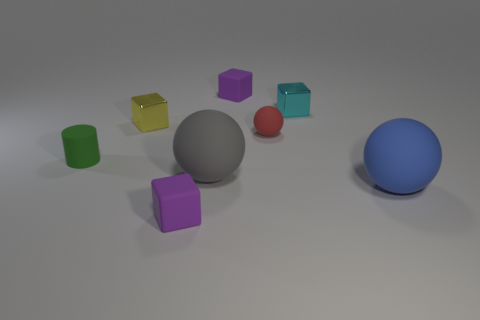Are there any other things that have the same material as the gray thing?
Your answer should be compact. Yes. How many small purple matte objects are to the right of the ball on the left side of the tiny purple cube behind the small rubber sphere?
Give a very brief answer. 1. What shape is the cyan thing that is the same material as the yellow thing?
Your response must be concise. Cube. The cyan cube that is in front of the purple matte object right of the small purple rubber thing that is in front of the small green matte object is made of what material?
Provide a succinct answer. Metal. How many things are purple objects in front of the blue ball or cyan things?
Provide a short and direct response. 2. What number of other objects are there of the same shape as the large blue matte object?
Give a very brief answer. 2. Are there more tiny cyan metallic objects that are to the right of the yellow shiny cube than small purple rubber cylinders?
Provide a short and direct response. Yes. There is a gray rubber object that is the same shape as the tiny red rubber thing; what size is it?
Your answer should be very brief. Large. The big blue thing has what shape?
Ensure brevity in your answer.  Sphere. There is a rubber thing that is the same size as the blue ball; what is its shape?
Ensure brevity in your answer.  Sphere. 